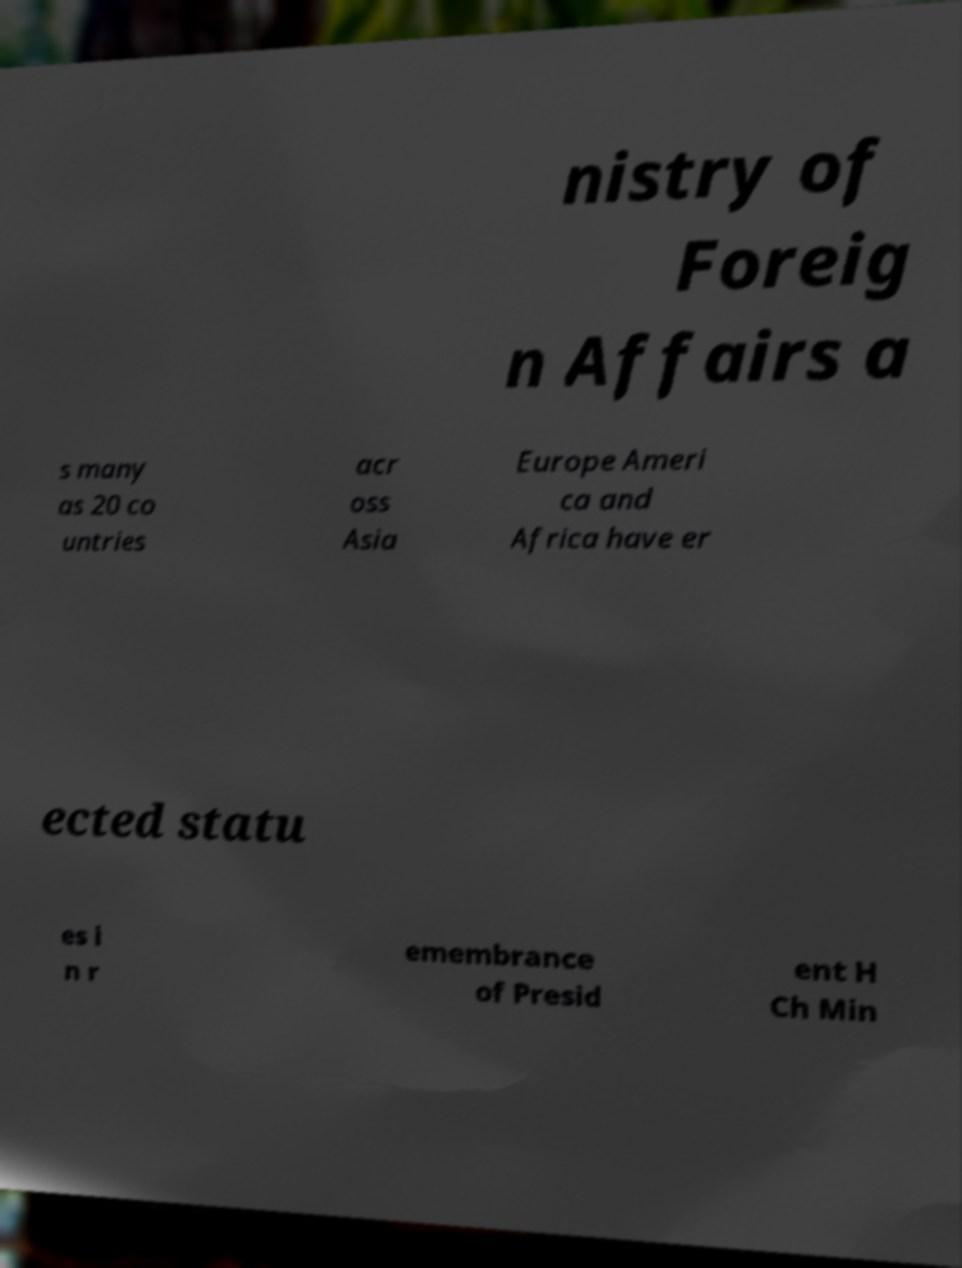I need the written content from this picture converted into text. Can you do that? nistry of Foreig n Affairs a s many as 20 co untries acr oss Asia Europe Ameri ca and Africa have er ected statu es i n r emembrance of Presid ent H Ch Min 